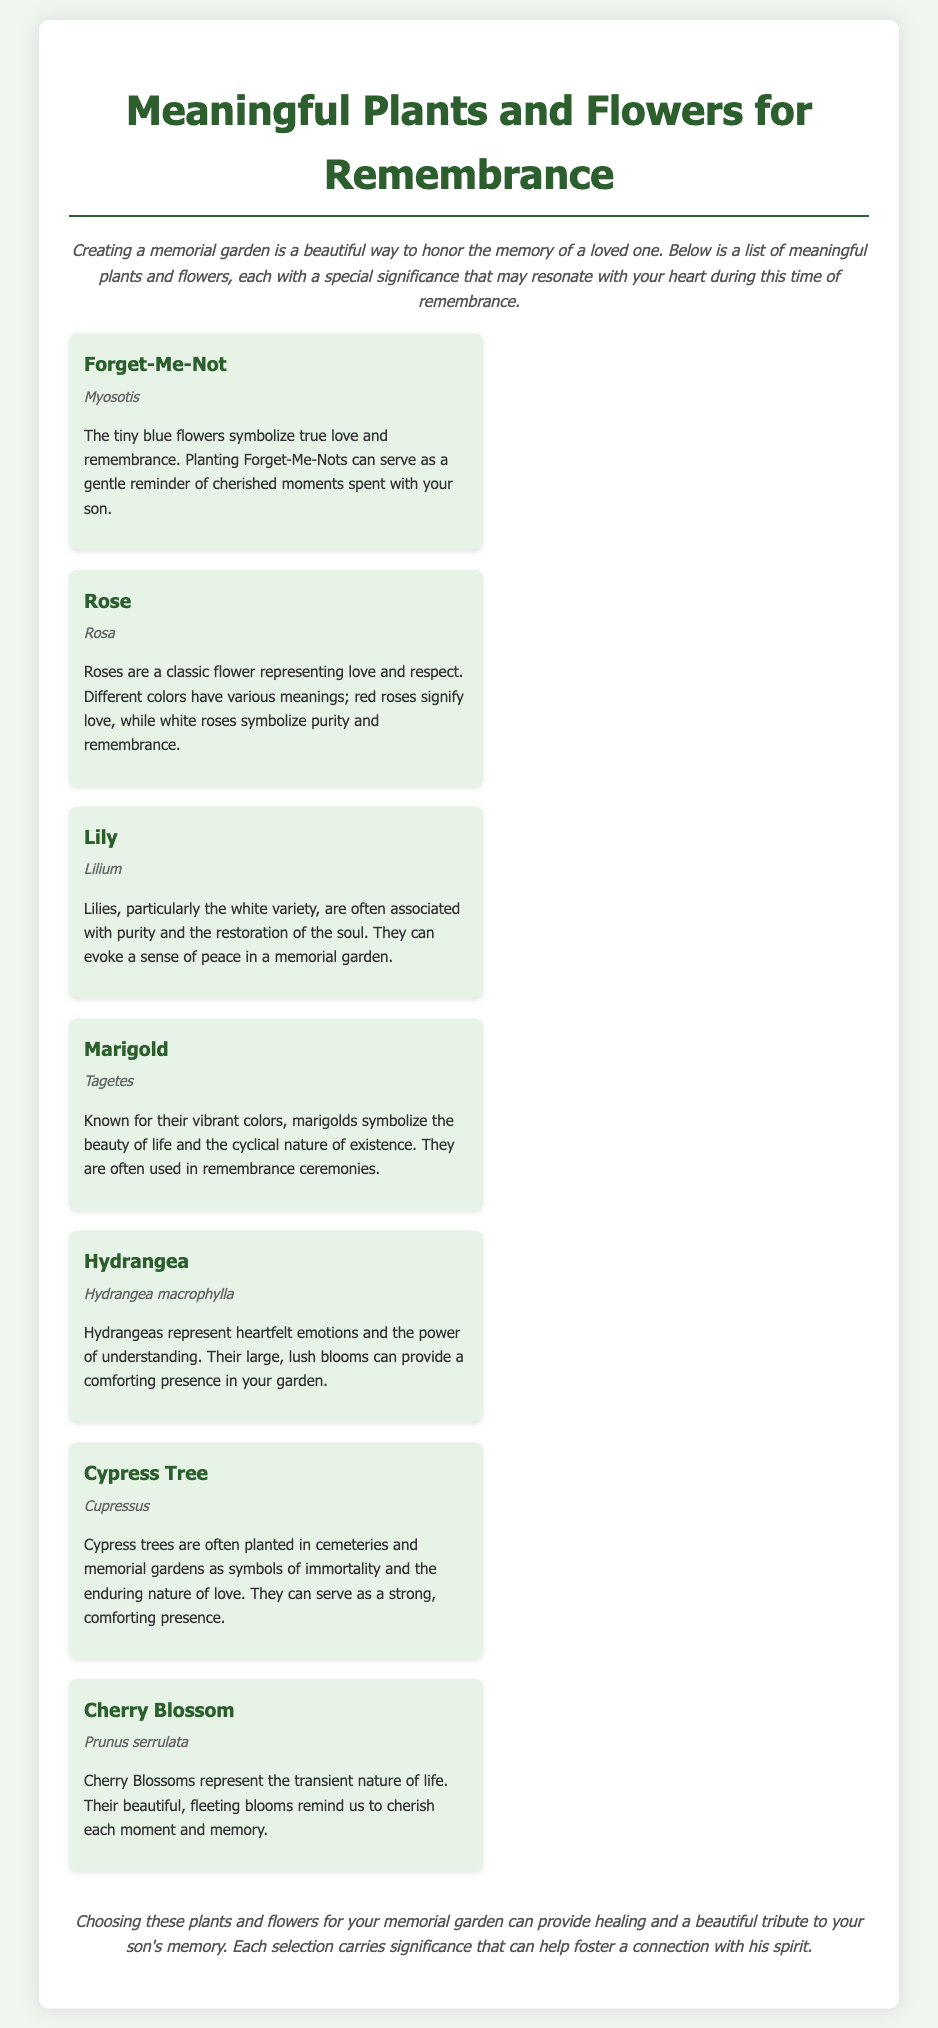What plant symbolizes true love and remembrance? The document states that Forget-Me-Nots symbolize true love and remembrance.
Answer: Forget-Me-Not What scientific name is associated with the Rose? The scientific name of the Rose provided in the document is Rosa.
Answer: Rosa Which flower is linked to the restoration of the soul? The document indicates that Lilies, particularly the white variety, are associated with the restoration of the soul.
Answer: Lily How do marigolds represent life? According to the document, marigolds symbolize the beauty of life and the cyclical nature of existence.
Answer: The beauty of life and the cyclical nature of existence What type of tree symbolizes immortality? The document mentions that Cypress trees are symbols of immortality.
Answer: Cypress Tree Which plant's flowers serve as a reminder to cherish each moment? The document states that Cherry Blossoms remind us to cherish each moment.
Answer: Cherry Blossom What does hydrangea represent in the garden? The significance of hydrangeas, as per the document, is described as heartfelt emotions and the power of understanding.
Answer: Heartfelt emotions and the power of understanding How many plants and flowers are listed in the document? The document lists a total of seven plants and flowers for remembrance.
Answer: Seven What is the primary purpose of the memorial garden as mentioned in the introduction? The introduction highlights that the purpose is to honor the memory of a loved one through the memorial garden.
Answer: To honor the memory of a loved one 